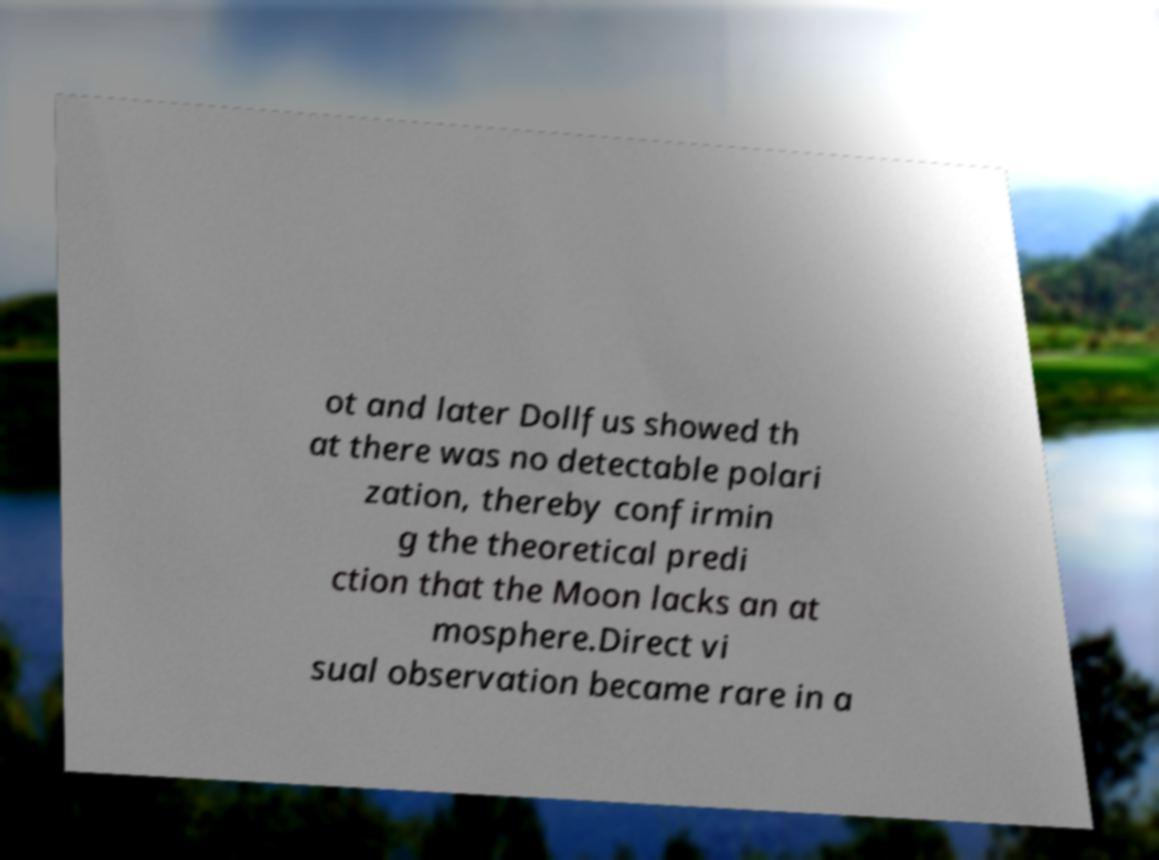There's text embedded in this image that I need extracted. Can you transcribe it verbatim? ot and later Dollfus showed th at there was no detectable polari zation, thereby confirmin g the theoretical predi ction that the Moon lacks an at mosphere.Direct vi sual observation became rare in a 